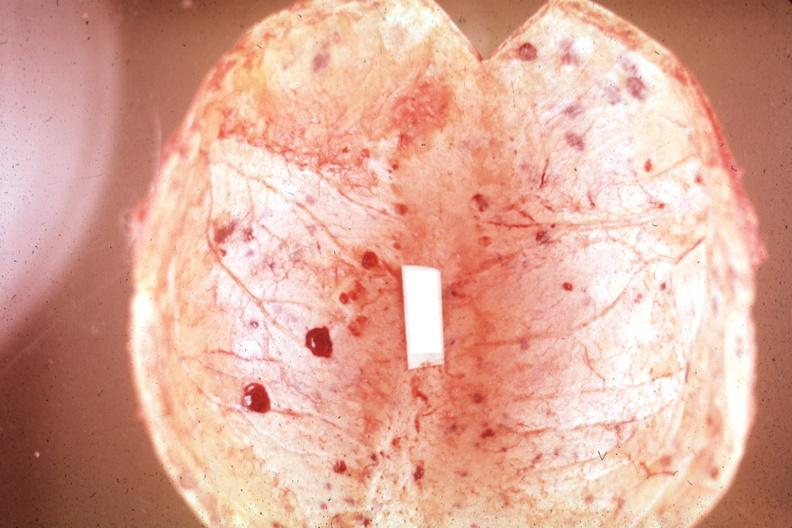s wrights single cell present?
Answer the question using a single word or phrase. No 